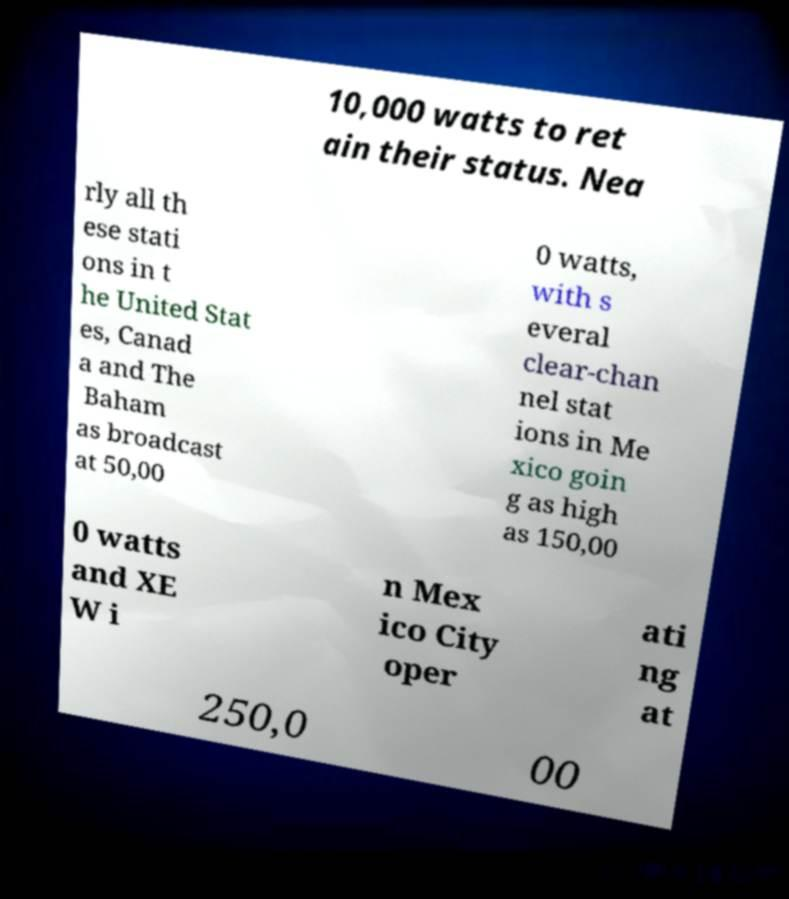What messages or text are displayed in this image? I need them in a readable, typed format. 10,000 watts to ret ain their status. Nea rly all th ese stati ons in t he United Stat es, Canad a and The Baham as broadcast at 50,00 0 watts, with s everal clear-chan nel stat ions in Me xico goin g as high as 150,00 0 watts and XE W i n Mex ico City oper ati ng at 250,0 00 